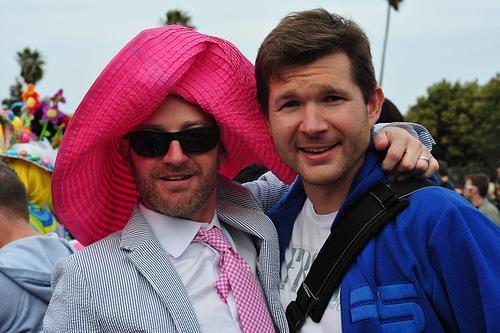How many people are looking at the camera?
Give a very brief answer. 2. How many hands are visible?
Give a very brief answer. 1. 